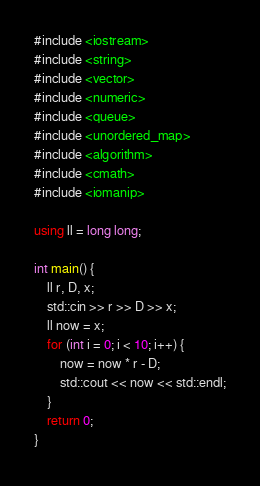Convert code to text. <code><loc_0><loc_0><loc_500><loc_500><_C++_>#include <iostream>
#include <string>
#include <vector>
#include <numeric>
#include <queue>
#include <unordered_map>
#include <algorithm>
#include <cmath>
#include <iomanip>

using ll = long long;

int main() {
    ll r, D, x;
    std::cin >> r >> D >> x;
    ll now = x;
    for (int i = 0; i < 10; i++) {
        now = now * r - D;
        std::cout << now << std::endl;
    }
    return 0;
}
</code> 